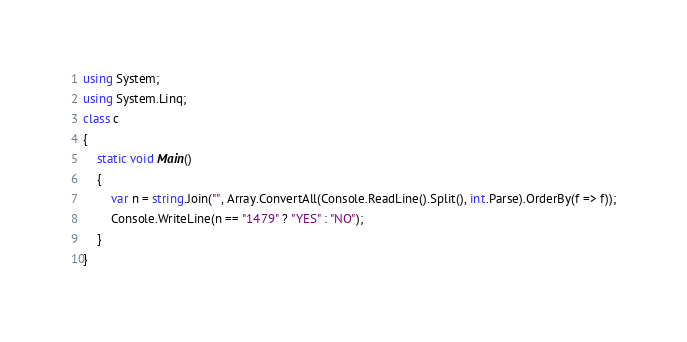Convert code to text. <code><loc_0><loc_0><loc_500><loc_500><_C#_>using System;
using System.Linq;
class c
{
    static void Main()
    {
        var n = string.Join("", Array.ConvertAll(Console.ReadLine().Split(), int.Parse).OrderBy(f => f));
        Console.WriteLine(n == "1479" ? "YES" : "NO");
    }
}</code> 